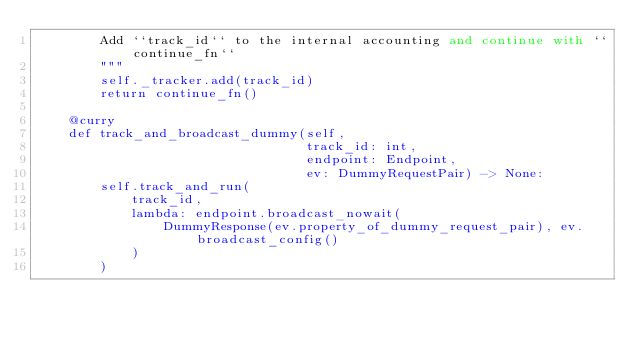Convert code to text. <code><loc_0><loc_0><loc_500><loc_500><_Python_>        Add ``track_id`` to the internal accounting and continue with ``continue_fn``
        """
        self._tracker.add(track_id)
        return continue_fn()

    @curry
    def track_and_broadcast_dummy(self,
                                  track_id: int,
                                  endpoint: Endpoint,
                                  ev: DummyRequestPair) -> None:
        self.track_and_run(
            track_id,
            lambda: endpoint.broadcast_nowait(
                DummyResponse(ev.property_of_dummy_request_pair), ev.broadcast_config()
            )
        )
</code> 